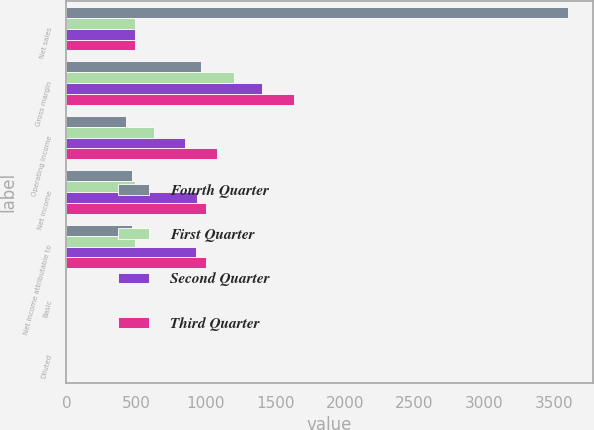Convert chart to OTSL. <chart><loc_0><loc_0><loc_500><loc_500><stacked_bar_chart><ecel><fcel>Net sales<fcel>Gross margin<fcel>Operating income<fcel>Net income<fcel>Net income attributable to<fcel>Basic<fcel>Diluted<nl><fcel>Fourth Quarter<fcel>3600<fcel>970<fcel>427<fcel>471<fcel>471<fcel>0.44<fcel>0.42<nl><fcel>First Quarter<fcel>491<fcel>1202<fcel>631<fcel>491<fcel>491<fcel>0.46<fcel>0.42<nl><fcel>Second Quarter<fcel>491<fcel>1405<fcel>855<fcel>935<fcel>934<fcel>0.87<fcel>0.78<nl><fcel>Third Quarter<fcel>491<fcel>1638<fcel>1085<fcel>1002<fcel>1003<fcel>0.94<fcel>0.84<nl></chart> 